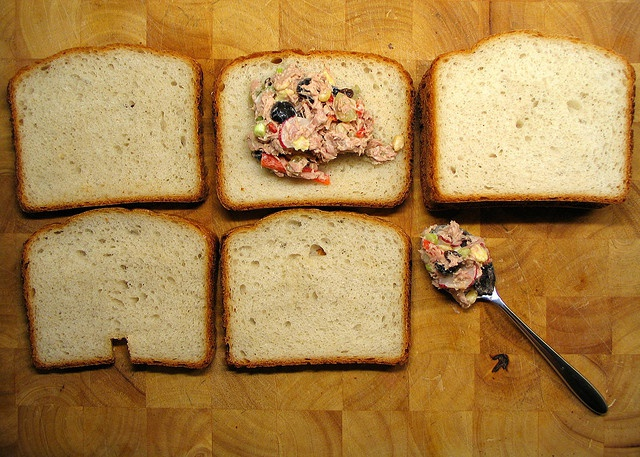Describe the objects in this image and their specific colors. I can see dining table in olive, khaki, tan, and maroon tones, sandwich in olive, khaki, lightyellow, black, and tan tones, sandwich in olive, tan, and brown tones, sandwich in olive and tan tones, and spoon in olive, black, tan, and maroon tones in this image. 